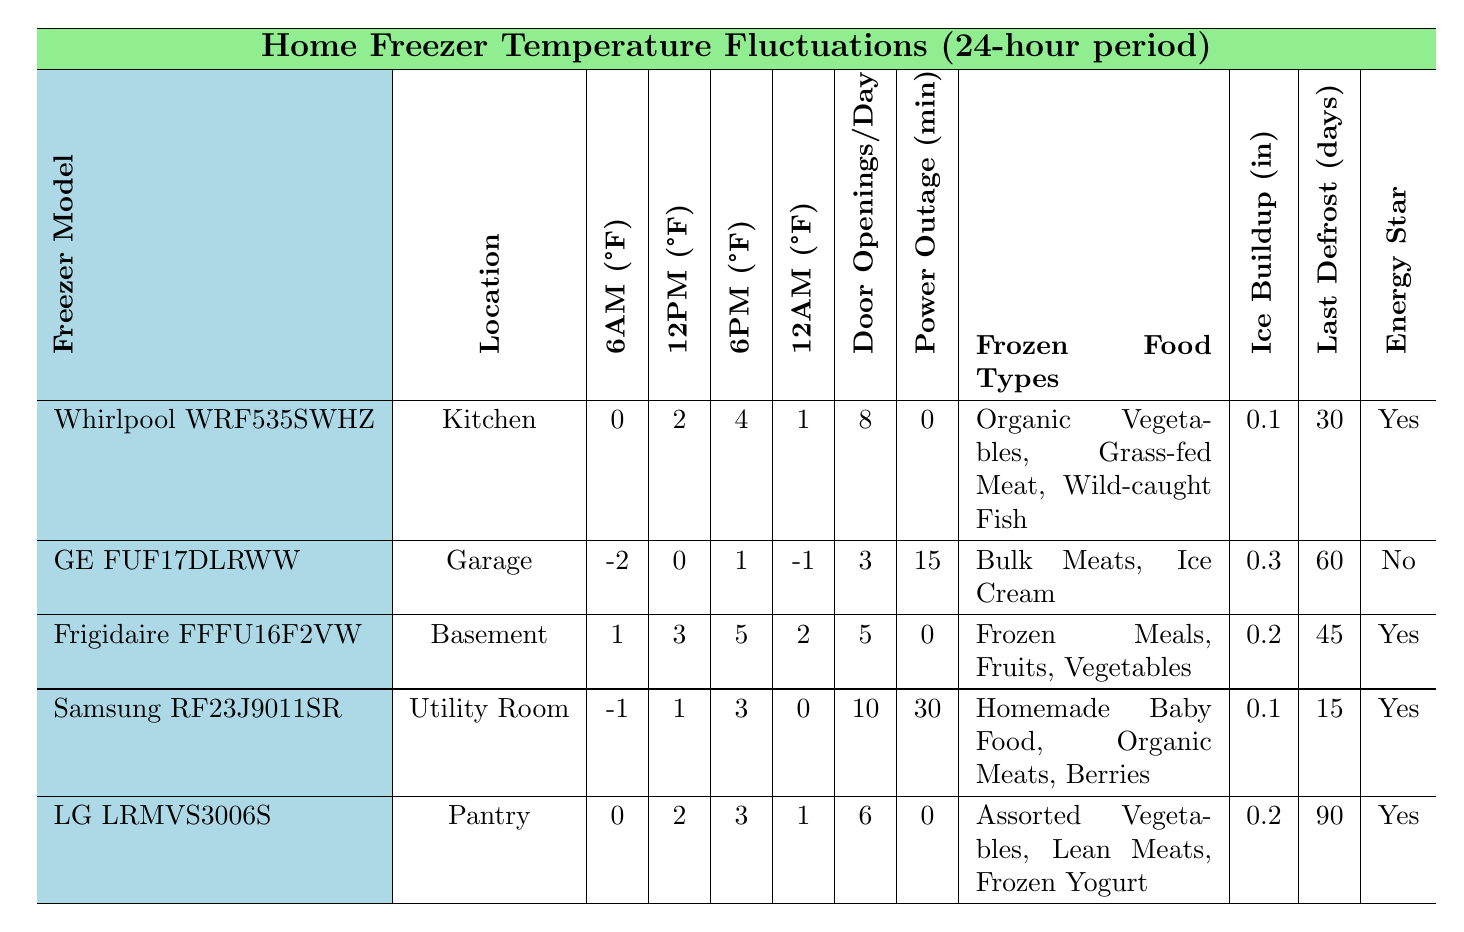What is the temperature of the Frigidaire FFFU16F2VW at 6 PM? The table shows the temperature for the Frigidaire FFFU16F2VW at 6 PM as 5°F.
Answer: 5°F Which freezer model has the lowest temperature recorded at 12 PM? The GE FUF17DLRWW has a recorded temperature of 0°F at 12 PM, which is the lowest compared to other models.
Answer: GE FUF17DLRWW How many door openings per day does the Samsung RF23J9011SR have? The Samsung RF23J9011SR has 10 door openings per day listed in the table.
Answer: 10 What is the average temperature at 6 AM across all freezers? The temperatures at 6 AM are 0, -2, 1, -1, and 0. The sum is (0 + -2 + 1 + -1 + 0) = -2, and the average is -2/5 = -0.4.
Answer: -0.4°F Is the LG LRMVS3006S Energy Star rated? Yes, the table indicates that the LG LRMVS3006S is Energy Star rated.
Answer: Yes What is the difference in temperature at 6 PM between the Whirlpool WRF535SWHZ and the GE FUF17DLRWW? The temperature for Whirlpool WRF535SWHZ at 6 PM is 4°F, and for GE FUF17DLRWW, it is 1°F. The difference is 4 - 1 = 3°F.
Answer: 3°F Which freezer has the longest duration since the last defrost? The LG LRMVS3006S has the longest duration since the last defrost at 90 days.
Answer: LG LRMVS3006S What types of food does the Frigidaire FFFU16F2VW store? The table specifies that the Frigidaire FFFU16F2VW holds Frozen Meals, Fruits, and Vegetables.
Answer: Frozen Meals, Fruits, Vegetables How does the ice buildup compare between the Whirlpool WRF535SWHZ and the Samsung RF23J9011SR? The Whirlpool WRF535SWHZ has 0.1 inches of ice buildup, while the Samsung RF23J9011SR has 0.1 inches as well. There is no difference between the two.
Answer: No difference Which freezer is located in the garage? The GE FUF17DLRWW is noted as being located in the garage.
Answer: GE FUF17DLRWW What is the power outage duration for the Frigidaire FFFU16F2VW? The table indicates that the Frigidaire FFFU16F2VW has a power outage duration of 0 minutes.
Answer: 0 minutes Is there a freezer that has a temperature of 0°F at any time during the 24-hour period? Yes, the GE FUF17DLRWW records 0°F at 12 PM and the Samsung RF23J9011SR records 0°F at 12 AM.
Answer: Yes 